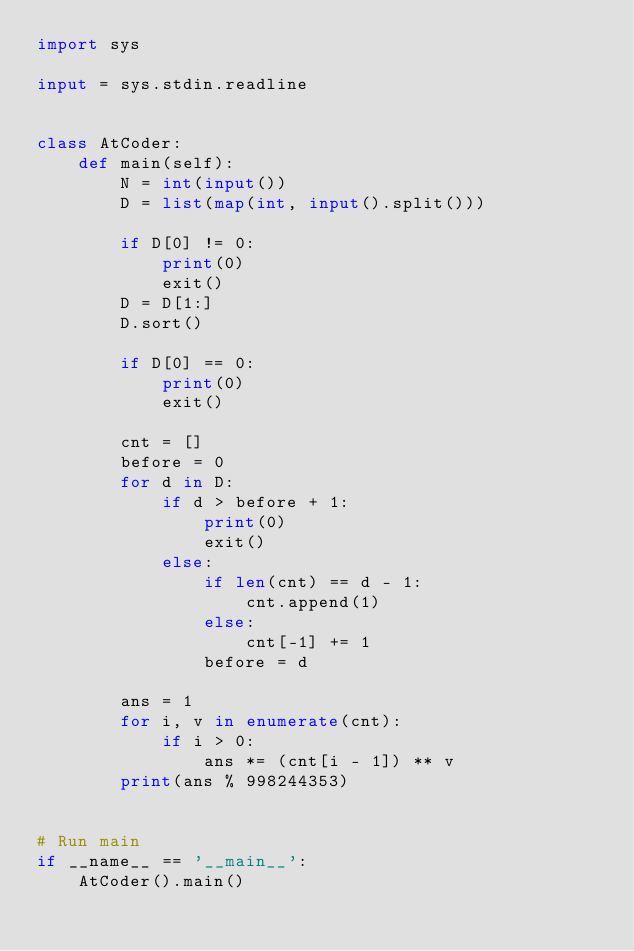Convert code to text. <code><loc_0><loc_0><loc_500><loc_500><_Python_>import sys

input = sys.stdin.readline


class AtCoder:
    def main(self):
        N = int(input())
        D = list(map(int, input().split()))

        if D[0] != 0:
            print(0)
            exit()
        D = D[1:]
        D.sort()

        if D[0] == 0:
            print(0)
            exit()

        cnt = []
        before = 0
        for d in D:
            if d > before + 1:
                print(0)
                exit()
            else:
                if len(cnt) == d - 1:
                    cnt.append(1)
                else:
                    cnt[-1] += 1
                before = d

        ans = 1
        for i, v in enumerate(cnt):
            if i > 0:
                ans *= (cnt[i - 1]) ** v
        print(ans % 998244353)


# Run main
if __name__ == '__main__':
    AtCoder().main()
</code> 